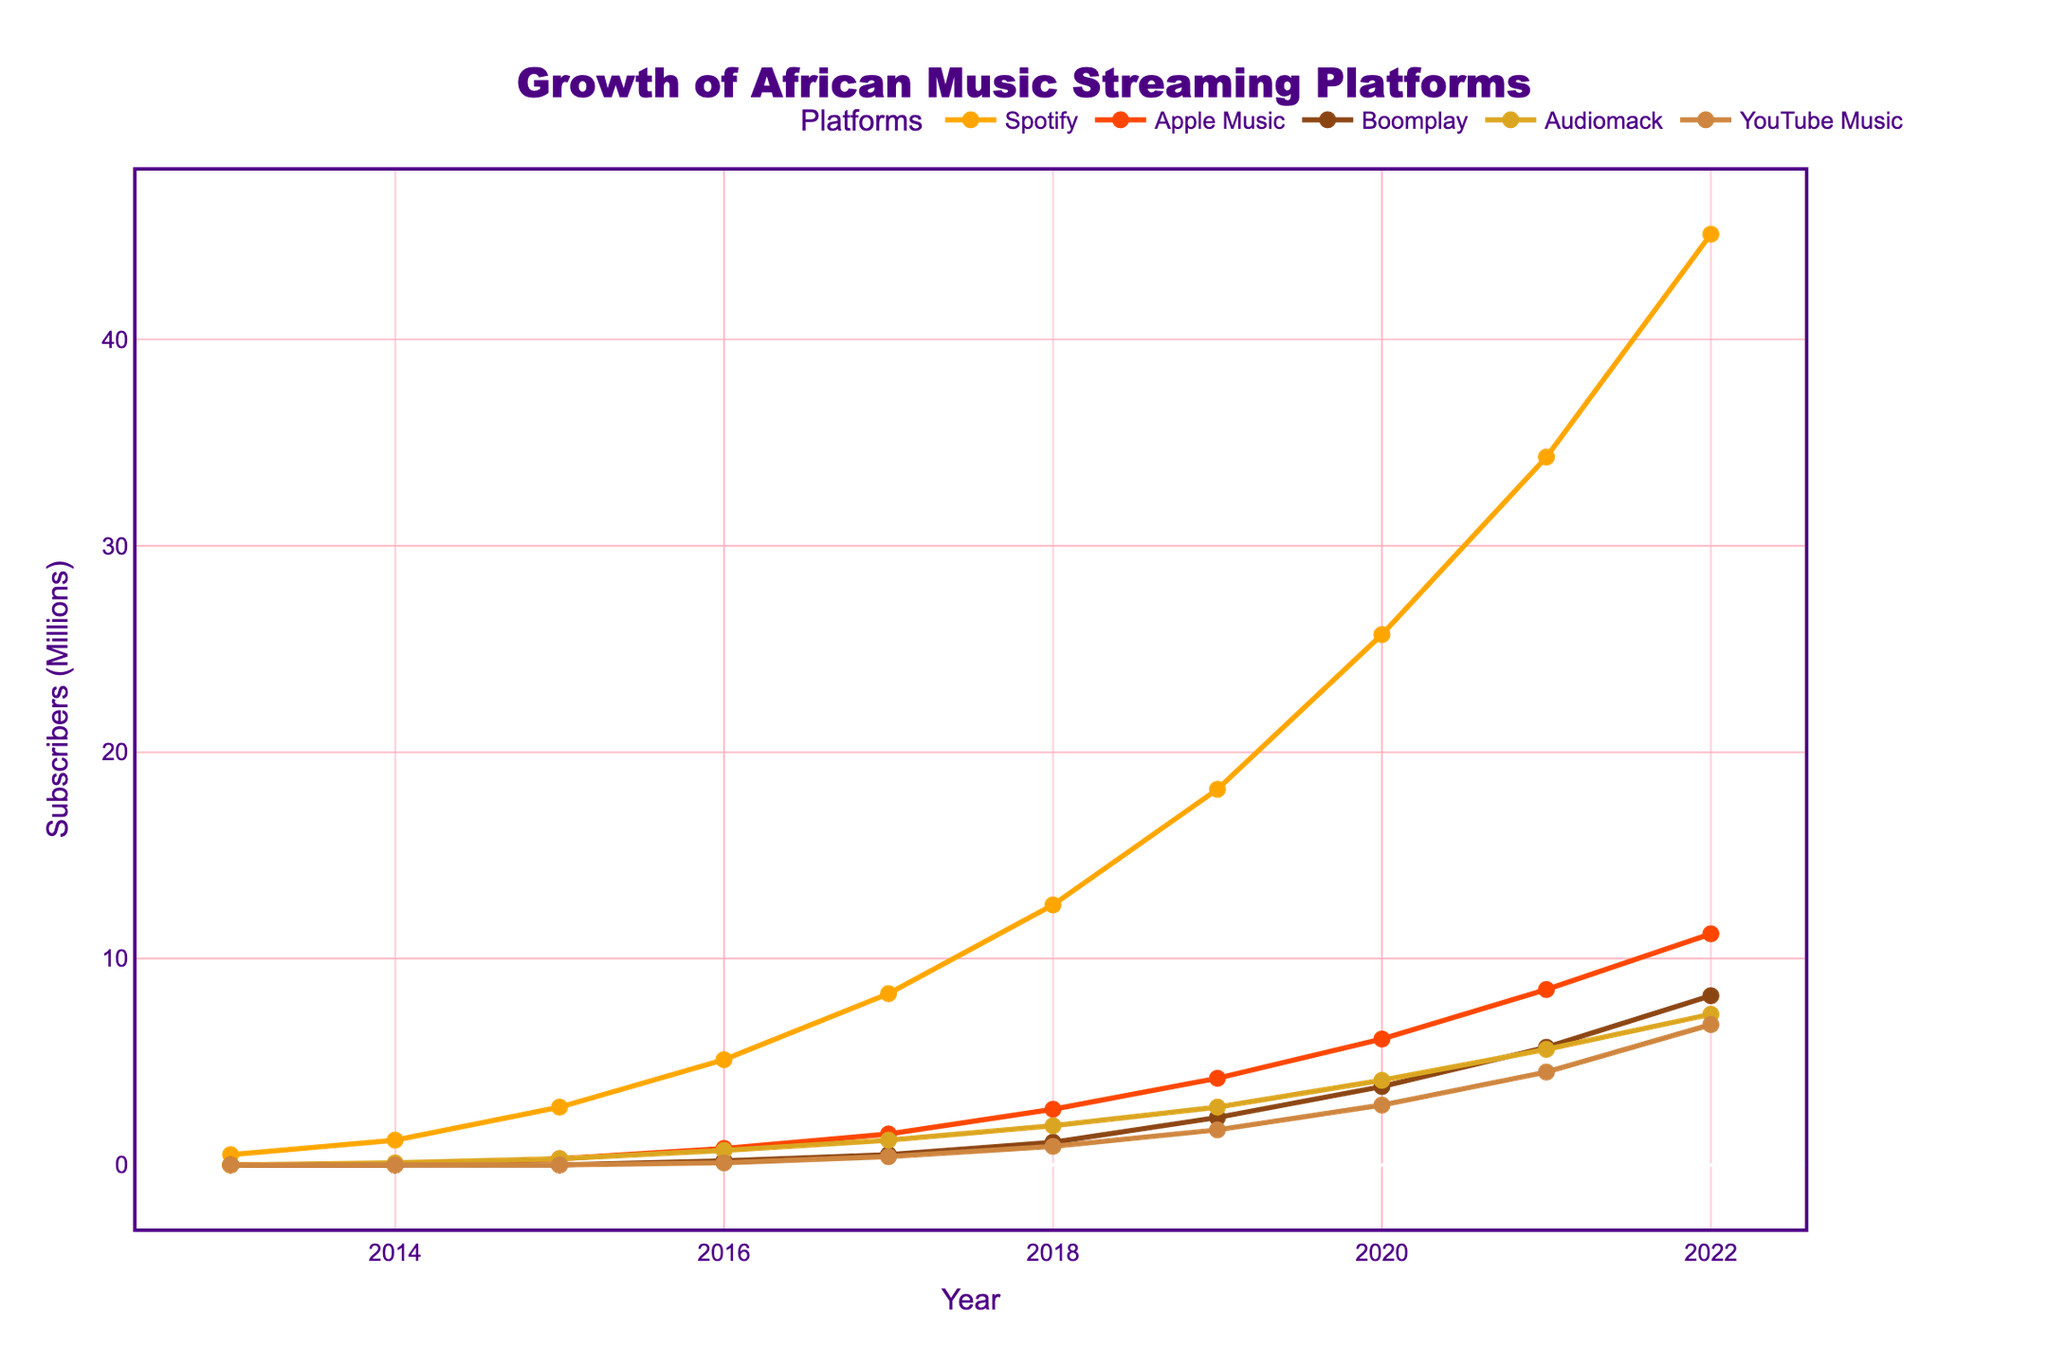What is the overall trend for Spotify's subscribers from 2013 to 2022? Looking at the line representing Spotify subscribers, we can see that it increases steadily from 0.5 million in 2013 to 45.1 million in 2022. This indicates a consistent upward trend over the decade.
Answer: Increasing trend Which platform had the highest number of subscribers in 2018? Observing the 2018 markers, Spotify's subscriber line is the highest at 12.6 million, compared to others like Apple Music at 2.7 million, Boomplay at 1.1 million, Audiomack at 1.9 million, and YouTube Music at 0.9 million.
Answer: Spotify How did the growth rate of Apple Music subscribers from 2019 to 2020 compare to that of Boomplay for the same period? For Apple Music, subscribers increased from 4.2 million in 2019 to 6.1 million in 2020, a growth of 1.9 million. For Boomplay, subscribers rose from 2.3 million to 3.8 million, a growth of 1.5 million. Apple Music's growth rate is higher.
Answer: Apple Music's growth rate is higher Which year did Audiomack surpass 5 million subscribers? Examining the subscriber line for Audiomack, it surpasses the 5 million mark in 2021.
Answer: 2021 By how much did YouTube Music's subscriber count increase between 2017 and 2022? YouTube Music had 0.4 million subscribers in 2017 and 6.8 million in 2022. The increase is calculated as 6.8 - 0.4 = 6.4 million.
Answer: 6.4 million Which platform shows the least growth between 2015 and 2020, and by how much? From 2015 to 2020, Boomplay grows from 0 to 3.8 million (3.8 million increase), Spotify from 2.8 to 25.7 million (22.9 million increase), Apple Music from 0.3 to 6.1 million (5.8 million increase), Audiomack from 0.3 to 4.1 million (3.8 million increase), and YouTube Music from 0 to 2.9 million (2.9 million increase). Boomplay shows the least growth of 3.8 million.
Answer: Boomplay, 3.8 million What is the combined total of subscribers for all platforms in 2022? Adding up the 2022 subscribers: Spotify (45.1), Apple Music (11.2), Boomplay (8.2), Audiomack (7.3), and YouTube Music (6.8). This totals to 45.1 + 11.2 + 8.2 + 7.3 + 6.8 = 78.6 million.
Answer: 78.6 million In which year did Spotify's subscriber count cease to be less than or equal to double that of Apple Music? In 2020, Spotify has 25.7 million subscribers while Apple Music has 6.1 million, which is double (12.2). In 2021, Spotify has 34.3 million and Apple Music 8.5 million (double 17), so 2020 is the last year when Spotify ≤ double Apple Music.
Answer: 2020 